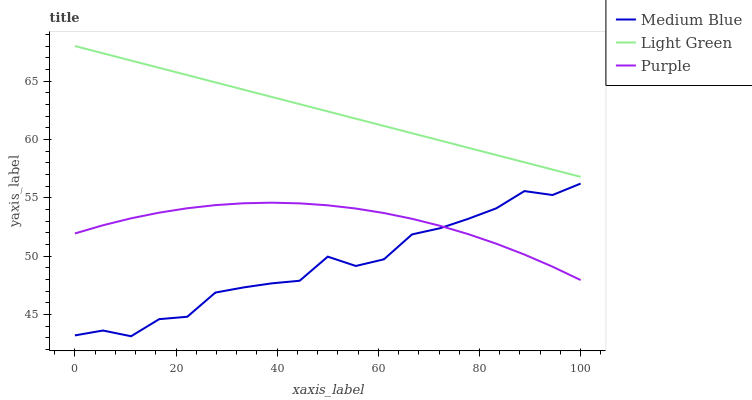Does Medium Blue have the minimum area under the curve?
Answer yes or no. Yes. Does Light Green have the maximum area under the curve?
Answer yes or no. Yes. Does Light Green have the minimum area under the curve?
Answer yes or no. No. Does Medium Blue have the maximum area under the curve?
Answer yes or no. No. Is Light Green the smoothest?
Answer yes or no. Yes. Is Medium Blue the roughest?
Answer yes or no. Yes. Is Medium Blue the smoothest?
Answer yes or no. No. Is Light Green the roughest?
Answer yes or no. No. Does Medium Blue have the lowest value?
Answer yes or no. Yes. Does Light Green have the lowest value?
Answer yes or no. No. Does Light Green have the highest value?
Answer yes or no. Yes. Does Medium Blue have the highest value?
Answer yes or no. No. Is Medium Blue less than Light Green?
Answer yes or no. Yes. Is Light Green greater than Purple?
Answer yes or no. Yes. Does Purple intersect Medium Blue?
Answer yes or no. Yes. Is Purple less than Medium Blue?
Answer yes or no. No. Is Purple greater than Medium Blue?
Answer yes or no. No. Does Medium Blue intersect Light Green?
Answer yes or no. No. 